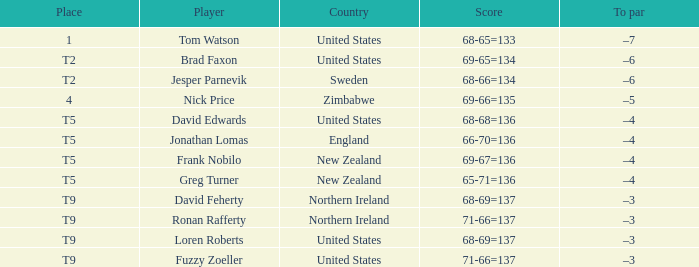The golfer in the first spot is from what country? United States. 